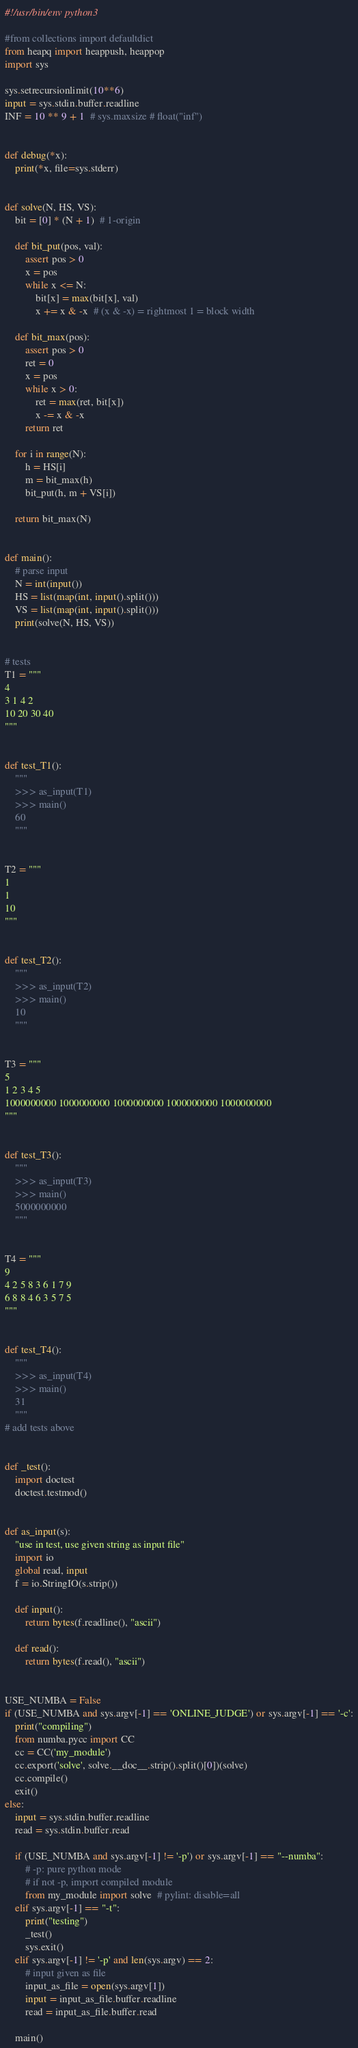Convert code to text. <code><loc_0><loc_0><loc_500><loc_500><_Python_>#!/usr/bin/env python3

#from collections import defaultdict
from heapq import heappush, heappop
import sys

sys.setrecursionlimit(10**6)
input = sys.stdin.buffer.readline
INF = 10 ** 9 + 1  # sys.maxsize # float("inf")


def debug(*x):
    print(*x, file=sys.stderr)


def solve(N, HS, VS):
    bit = [0] * (N + 1)  # 1-origin

    def bit_put(pos, val):
        assert pos > 0
        x = pos
        while x <= N:
            bit[x] = max(bit[x], val)
            x += x & -x  # (x & -x) = rightmost 1 = block width

    def bit_max(pos):
        assert pos > 0
        ret = 0
        x = pos
        while x > 0:
            ret = max(ret, bit[x])
            x -= x & -x
        return ret

    for i in range(N):
        h = HS[i]
        m = bit_max(h)
        bit_put(h, m + VS[i])

    return bit_max(N)


def main():
    # parse input
    N = int(input())
    HS = list(map(int, input().split()))
    VS = list(map(int, input().split()))
    print(solve(N, HS, VS))


# tests
T1 = """
4
3 1 4 2
10 20 30 40
"""


def test_T1():
    """
    >>> as_input(T1)
    >>> main()
    60
    """


T2 = """
1
1
10
"""


def test_T2():
    """
    >>> as_input(T2)
    >>> main()
    10
    """


T3 = """
5
1 2 3 4 5
1000000000 1000000000 1000000000 1000000000 1000000000
"""


def test_T3():
    """
    >>> as_input(T3)
    >>> main()
    5000000000
    """


T4 = """
9
4 2 5 8 3 6 1 7 9
6 8 8 4 6 3 5 7 5
"""


def test_T4():
    """
    >>> as_input(T4)
    >>> main()
    31
    """
# add tests above


def _test():
    import doctest
    doctest.testmod()


def as_input(s):
    "use in test, use given string as input file"
    import io
    global read, input
    f = io.StringIO(s.strip())

    def input():
        return bytes(f.readline(), "ascii")

    def read():
        return bytes(f.read(), "ascii")


USE_NUMBA = False
if (USE_NUMBA and sys.argv[-1] == 'ONLINE_JUDGE') or sys.argv[-1] == '-c':
    print("compiling")
    from numba.pycc import CC
    cc = CC('my_module')
    cc.export('solve', solve.__doc__.strip().split()[0])(solve)
    cc.compile()
    exit()
else:
    input = sys.stdin.buffer.readline
    read = sys.stdin.buffer.read

    if (USE_NUMBA and sys.argv[-1] != '-p') or sys.argv[-1] == "--numba":
        # -p: pure python mode
        # if not -p, import compiled module
        from my_module import solve  # pylint: disable=all
    elif sys.argv[-1] == "-t":
        print("testing")
        _test()
        sys.exit()
    elif sys.argv[-1] != '-p' and len(sys.argv) == 2:
        # input given as file
        input_as_file = open(sys.argv[1])
        input = input_as_file.buffer.readline
        read = input_as_file.buffer.read

    main()
</code> 